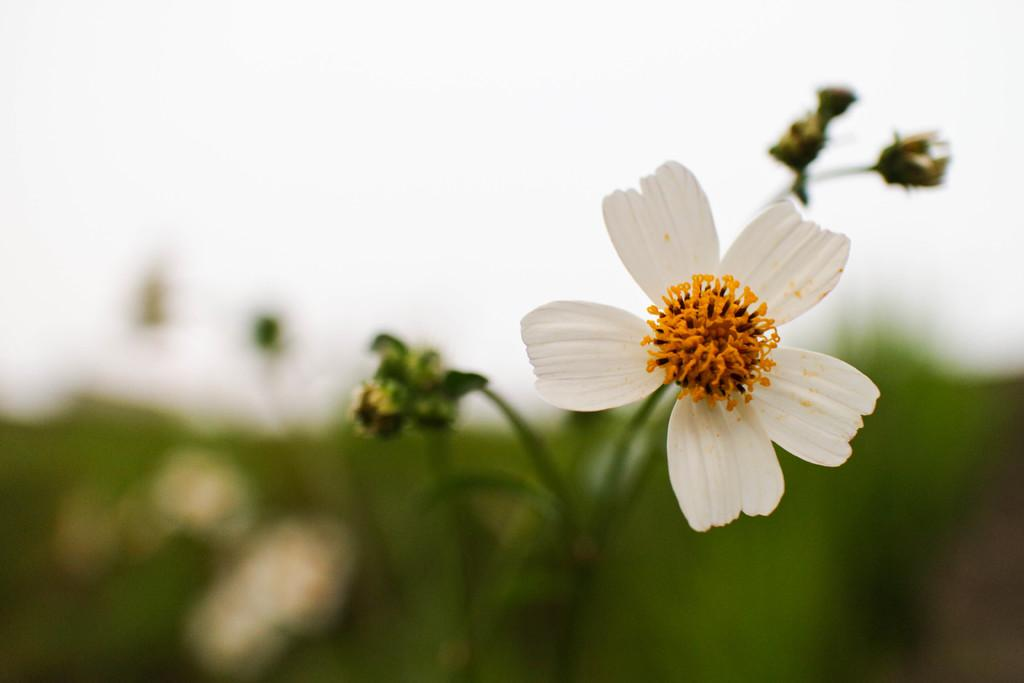What type of living organisms can be seen in the image? Plants can be seen in the image. Can you describe any specific features of the plants? Yes, there is a flower on one of the plants. What is the appearance of the background in the image? The background of the image is blurred. Can you tell me how many toads are sitting on the plants in the image? There are no toads present in the image; it features plants with a flower. Are there any girls driving vehicles in the image? There are no girls or vehicles present in the image. 